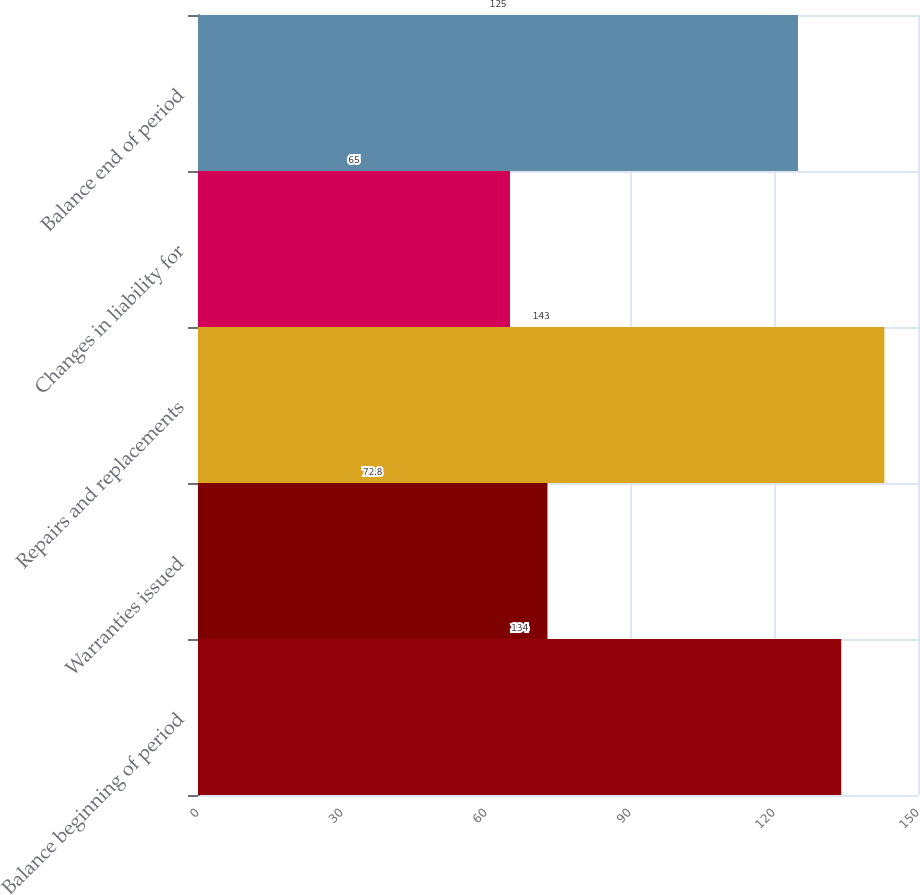<chart> <loc_0><loc_0><loc_500><loc_500><bar_chart><fcel>Balance beginning of period<fcel>Warranties issued<fcel>Repairs and replacements<fcel>Changes in liability for<fcel>Balance end of period<nl><fcel>134<fcel>72.8<fcel>143<fcel>65<fcel>125<nl></chart> 